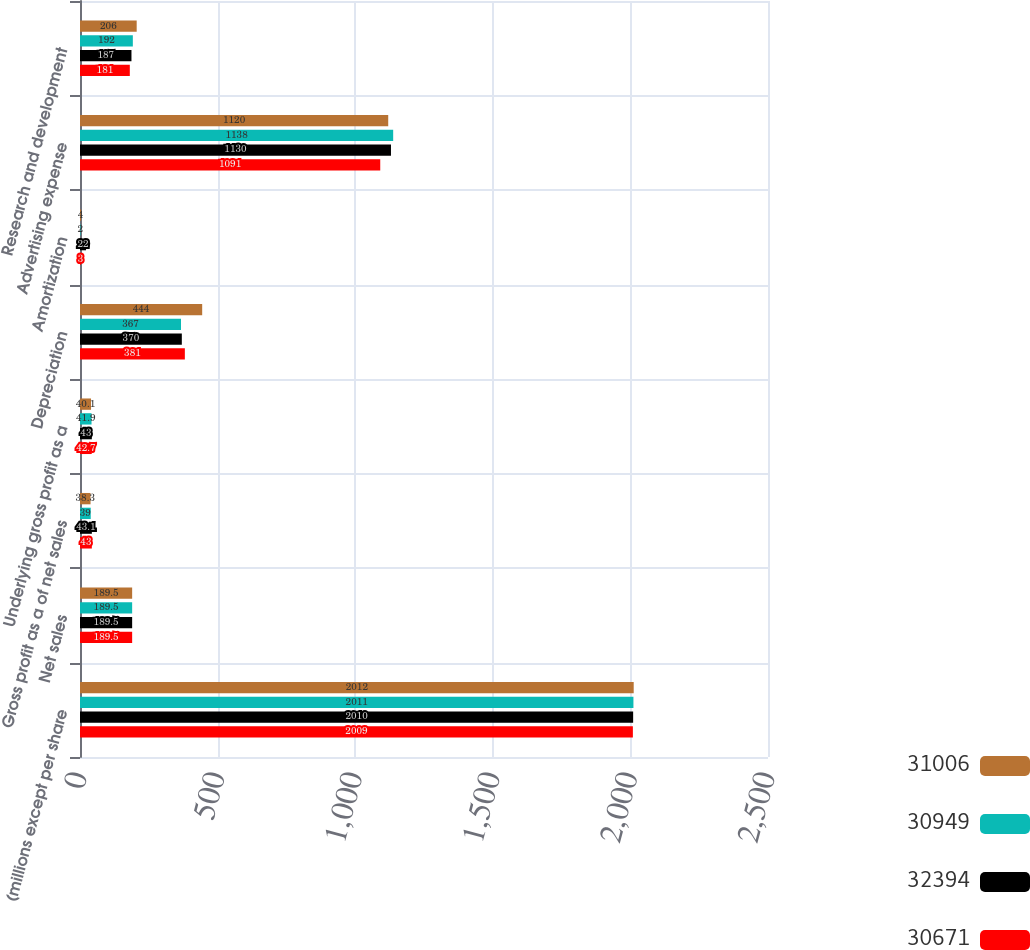Convert chart to OTSL. <chart><loc_0><loc_0><loc_500><loc_500><stacked_bar_chart><ecel><fcel>(millions except per share<fcel>Net sales<fcel>Gross profit as a of net sales<fcel>Underlying gross profit as a<fcel>Depreciation<fcel>Amortization<fcel>Advertising expense<fcel>Research and development<nl><fcel>31006<fcel>2012<fcel>189.5<fcel>38.3<fcel>40.1<fcel>444<fcel>4<fcel>1120<fcel>206<nl><fcel>30949<fcel>2011<fcel>189.5<fcel>39<fcel>41.9<fcel>367<fcel>2<fcel>1138<fcel>192<nl><fcel>32394<fcel>2010<fcel>189.5<fcel>43.1<fcel>43<fcel>370<fcel>22<fcel>1130<fcel>187<nl><fcel>30671<fcel>2009<fcel>189.5<fcel>43<fcel>42.7<fcel>381<fcel>3<fcel>1091<fcel>181<nl></chart> 